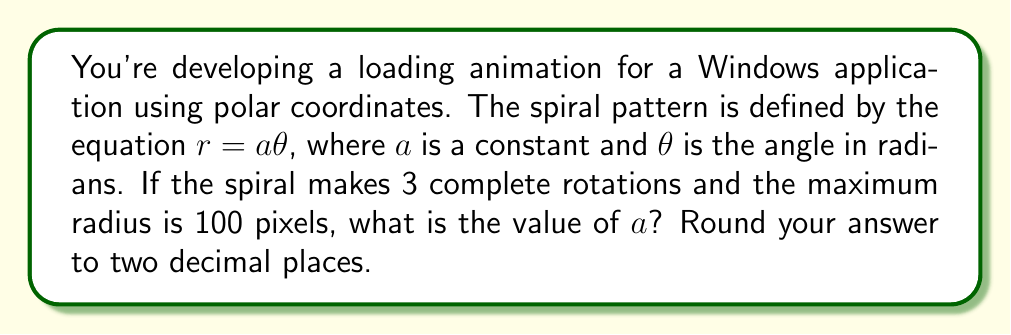Could you help me with this problem? Let's break this down step-by-step:

1) In polar coordinates, a spiral is often represented by the equation $r = a\theta$, where:
   - $r$ is the radius (distance from the origin)
   - $a$ is a constant that determines how tightly the spiral is wound
   - $\theta$ is the angle in radians

2) We're told that the spiral makes 3 complete rotations. In radians, one complete rotation is $2\pi$. So, 3 rotations would be:

   $\theta_{max} = 3 \cdot 2\pi = 6\pi$ radians

3) We're also told that the maximum radius is 100 pixels. This occurs at the end of the 3 rotations. So we can write:

   $r_{max} = 100 = a \cdot \theta_{max}$

4) Substituting what we know:

   $100 = a \cdot 6\pi$

5) Now we can solve for $a$:

   $a = \frac{100}{6\pi} \approx 5.3052$

6) Rounding to two decimal places:

   $a \approx 5.31$

This value of $a$ will create a spiral that makes exactly 3 rotations and reaches a maximum radius of 100 pixels.
Answer: $a \approx 5.31$ 